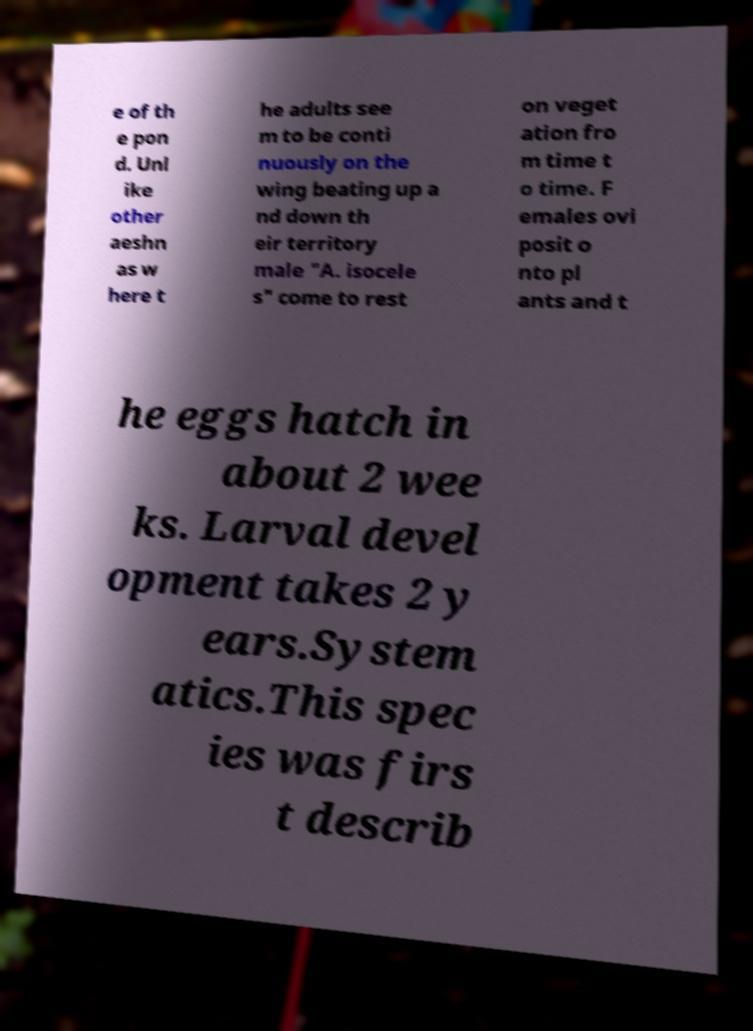What messages or text are displayed in this image? I need them in a readable, typed format. e of th e pon d. Unl ike other aeshn as w here t he adults see m to be conti nuously on the wing beating up a nd down th eir territory male "A. isocele s" come to rest on veget ation fro m time t o time. F emales ovi posit o nto pl ants and t he eggs hatch in about 2 wee ks. Larval devel opment takes 2 y ears.System atics.This spec ies was firs t describ 